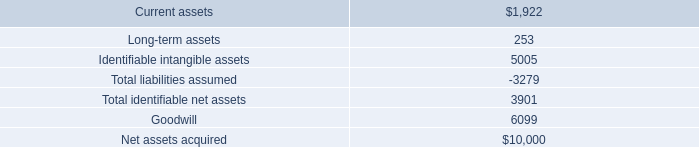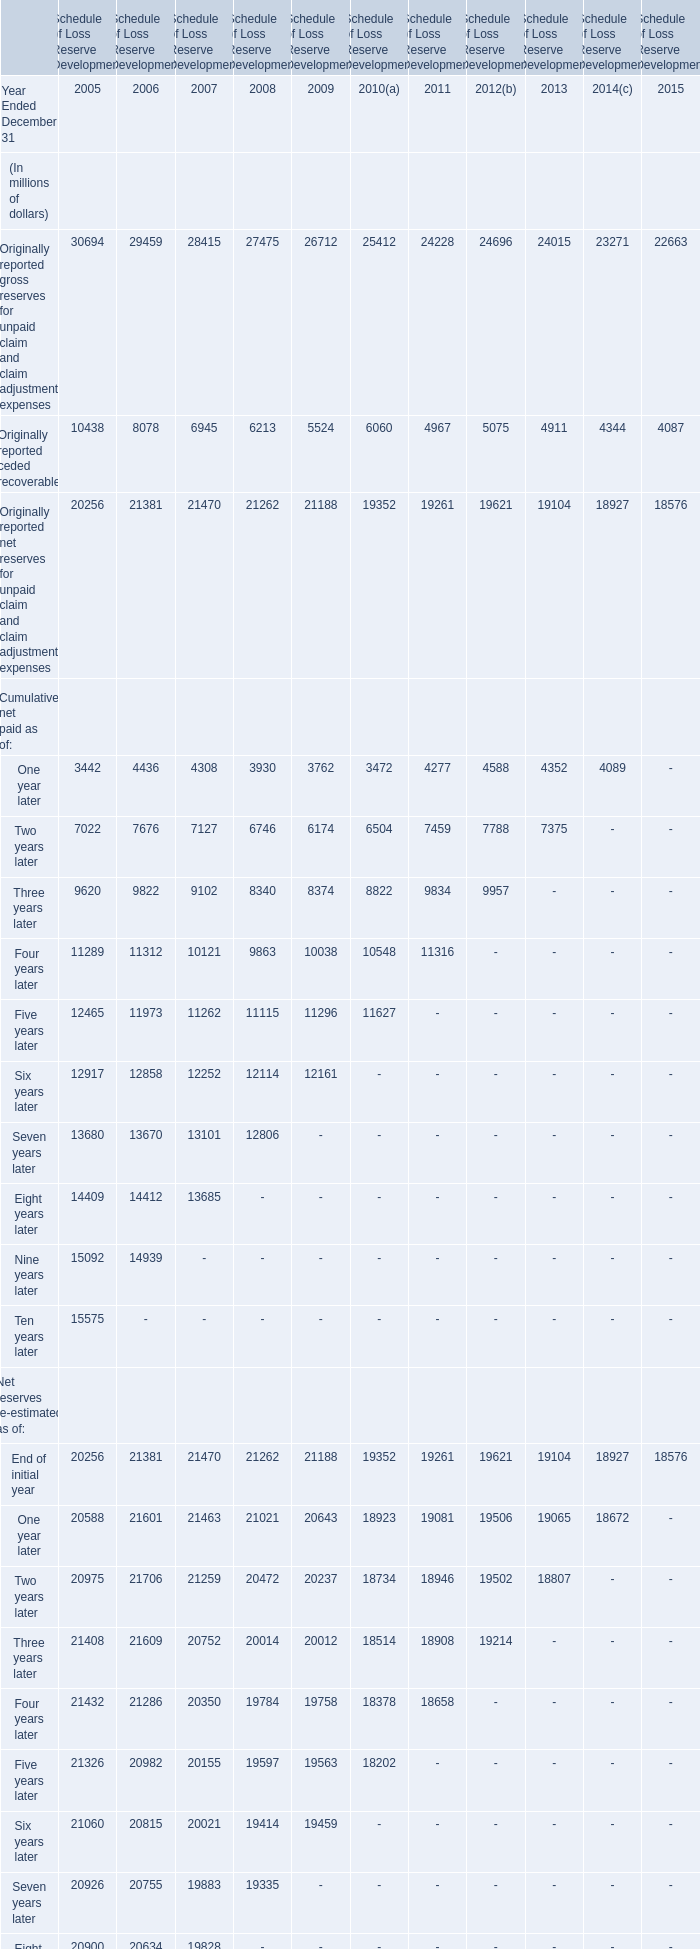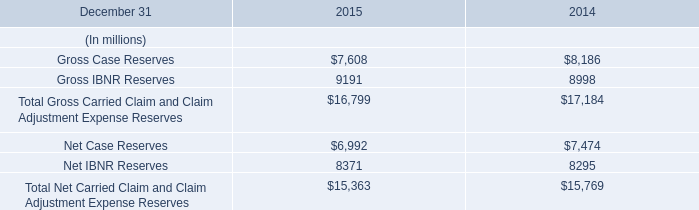What's the current growth rate of the amount for originally reported ceded recoverable? 
Computations: ((4087 - 4344) / 4344)
Answer: -0.05916. 